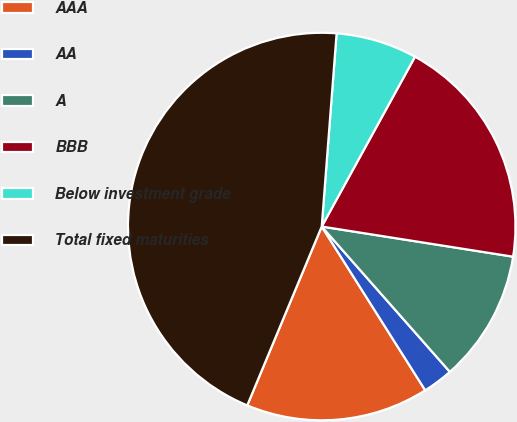Convert chart. <chart><loc_0><loc_0><loc_500><loc_500><pie_chart><fcel>AAA<fcel>AA<fcel>A<fcel>BBB<fcel>Below investment grade<fcel>Total fixed maturities<nl><fcel>15.25%<fcel>2.53%<fcel>11.01%<fcel>19.49%<fcel>6.77%<fcel>44.94%<nl></chart> 